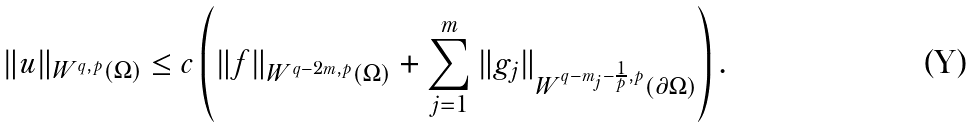Convert formula to latex. <formula><loc_0><loc_0><loc_500><loc_500>\| u \| _ { W ^ { q , p } ( \Omega ) } \leq c \left ( \| f \| _ { W ^ { q - 2 m , p } ( \Omega ) } + \sum _ { j = 1 } ^ { m } \| g _ { j } \| _ { W ^ { q - m _ { j } - \frac { 1 } { p } , p } ( \partial \Omega ) } \right ) .</formula> 